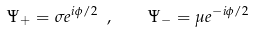Convert formula to latex. <formula><loc_0><loc_0><loc_500><loc_500>\Psi _ { + } = \sigma e ^ { i \phi / 2 } \ , \quad \Psi _ { - } = \mu e ^ { - i \phi / 2 }</formula> 